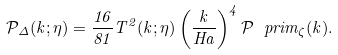<formula> <loc_0><loc_0><loc_500><loc_500>\mathcal { P } _ { \Delta } ( k ; \eta ) = \frac { 1 6 } { 8 1 } T ^ { 2 } ( k ; \eta ) \left ( \frac { k } { H a } \right ) ^ { 4 } \mathcal { P } ^ { \ } p r i m _ { \zeta } ( k ) .</formula> 